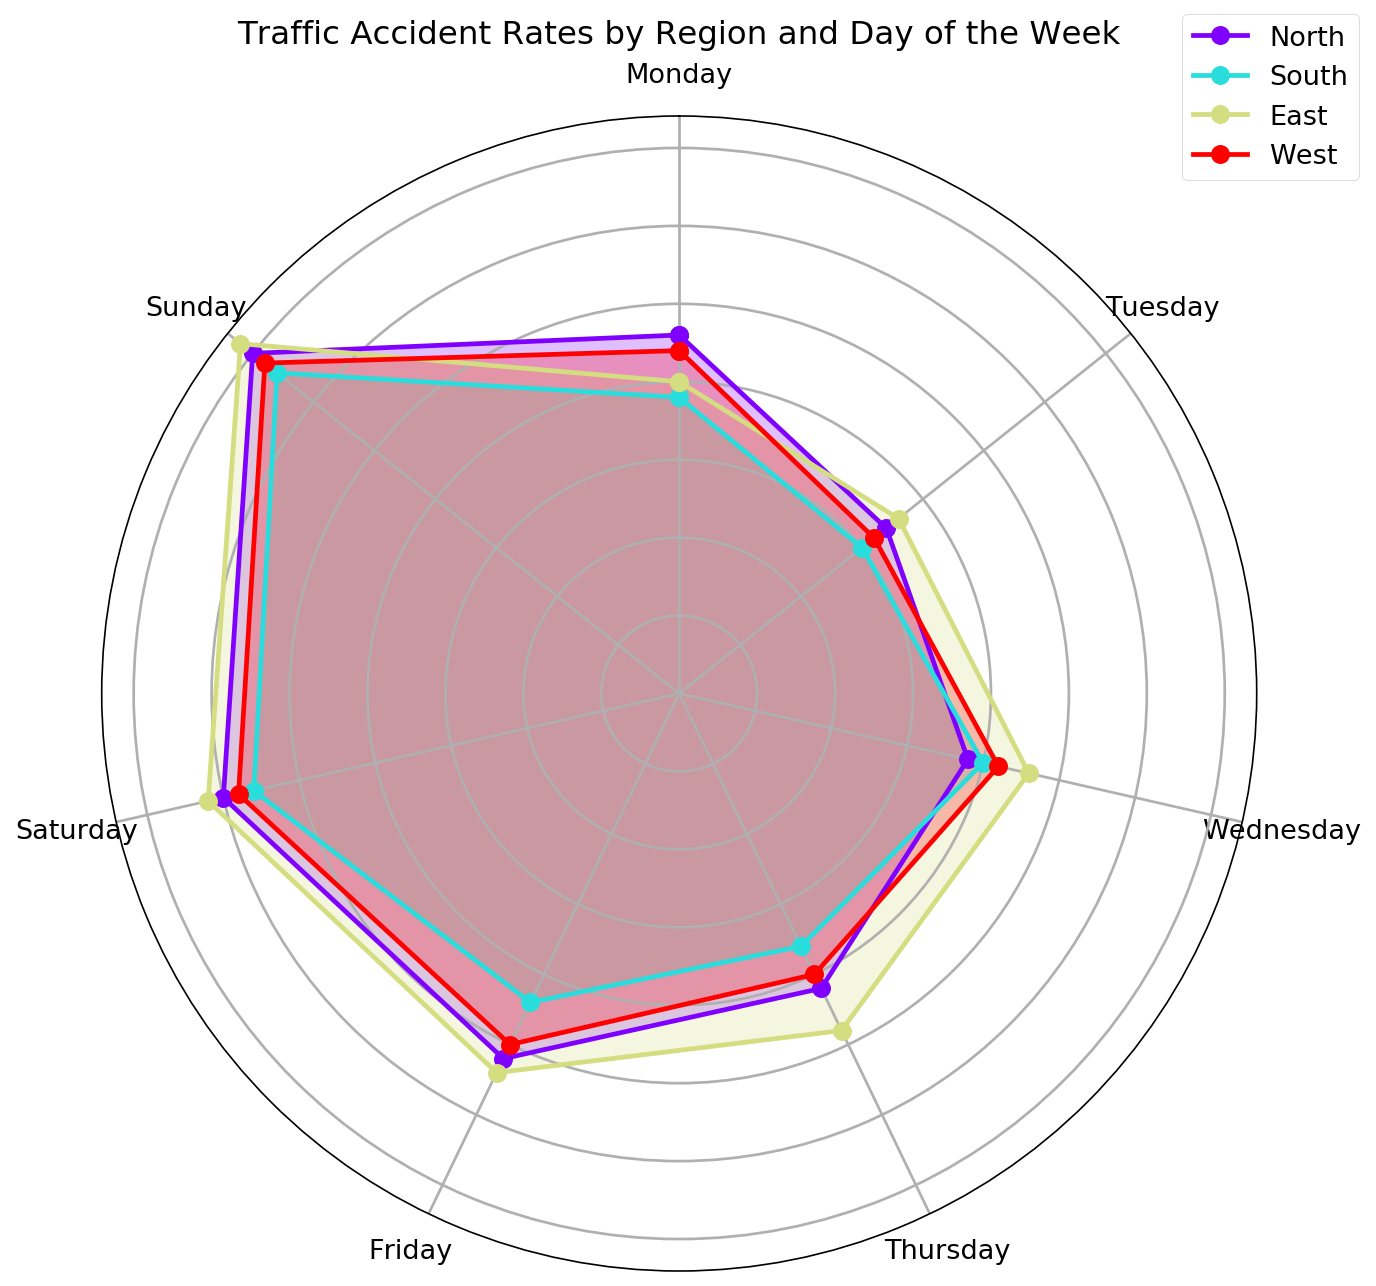What is the highest traffic accident count recorded on a Sunday? To find the highest traffic accident count on a Sunday, look at the values for Sunday across all regions. The North records 35, South records 33, East records 36, and West records 34. The highest among these is 36.
Answer: 36 Which region has the lowest accident count on a Tuesday? To determine the region with the lowest accident count on a Tuesday, examine the values: North has 17, South has 15, East has 18, and West has 16. The lowest value is 15, which belongs to the South.
Answer: South What is the average accident count in the North region from Monday to Sunday? Add up the accident counts for the North region from Monday to Sunday: 23 + 17 + 19 + 21 + 26 + 30 + 35 = 171. There are 7 days, so divide the total by 7. The average is 171 / 7 = 24.43.
Answer: 24.43 By how many does the accident count on Fridays in the East region exceed that in the South region? First, identify the accident counts for Friday in both the East (27) and South (22). Subtract the South’s count from the East’s: 27 - 22 = 5.
Answer: 5 Which region shows the largest increase in accident count from Monday to Sunday? Calculate the difference between the accident counts on Sunday and Monday for each region: North: 35 - 23 = 12, South: 33 - 19 = 14, East: 36 - 20 = 16, West: 34 - 22 = 12. The East region has the largest increase, which is 16.
Answer: East If we merge the North and South regions, what will be the average accident count on Saturdays? Combine the accident counts for Saturday from the North and South: 30 (North) + 28 (South) = 58. Since there are two regions, the average is 58 / 2 = 29.
Answer: 29 How does the accident count on Wednesdays in the West region compare to that on Mondays? Identify the accident counts for Wednesday and Monday in the West region: Monday 22, Wednesday 21. The difference is 22 - 21 = 1, indicating the count on Monday is higher by 1.
Answer: Monday by 1 